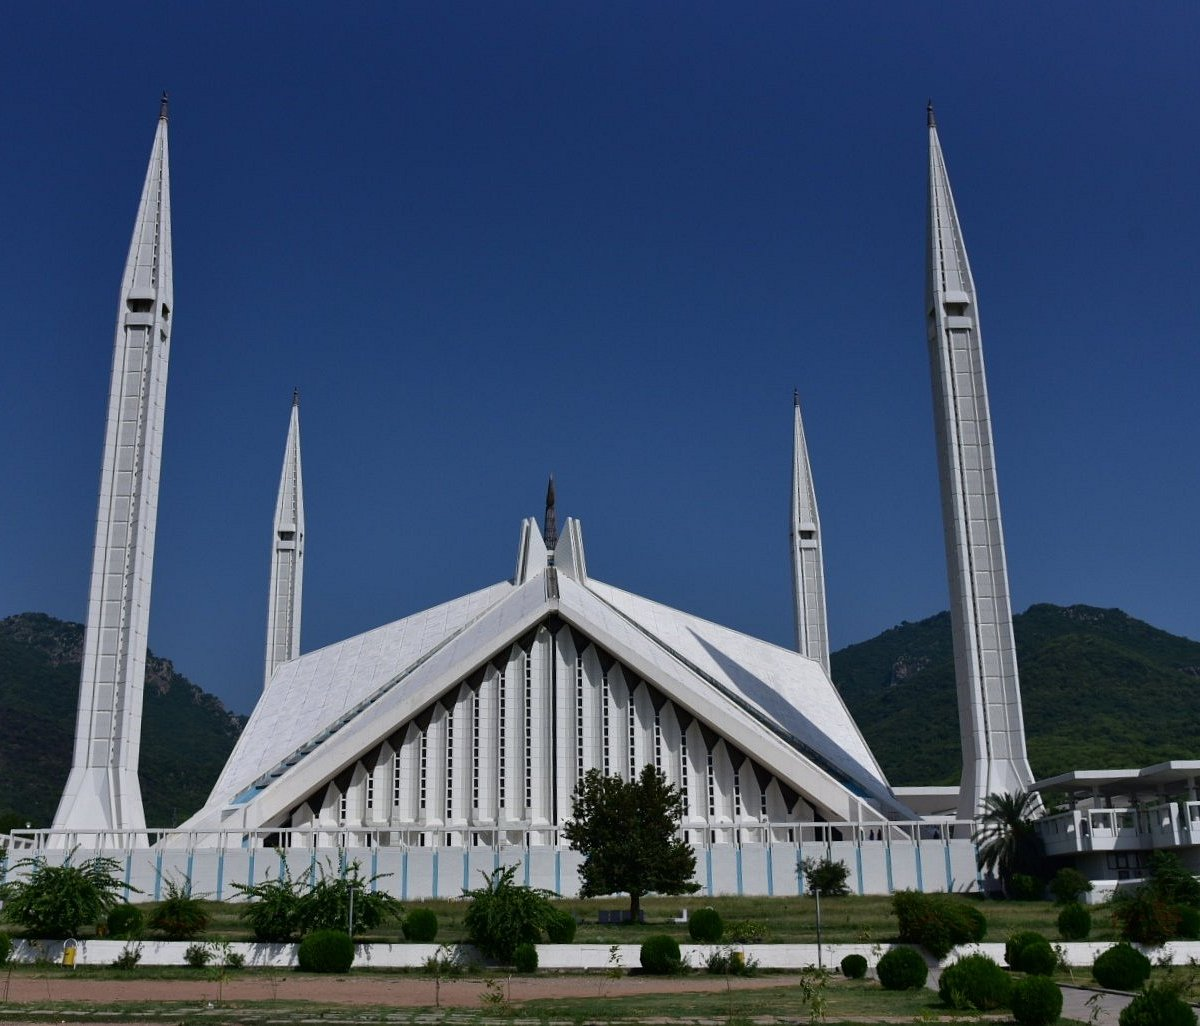How does the landscape around the mosque enhance its visual appeal? The landscape surrounding Faisal Mosque significantly enhances its visual appeal by providing a stunning natural backdrop to the stark, geometric lines of the mosque. Nestled at the foot of the Margalla Hills, the mosque's brilliant white structure stands out against the lush greenery of the hills. This contrast not only emphasizes the mosque's architectural elegance but also creates a tranquil, contemplative environment that invites both reflection and admiration from observers. 